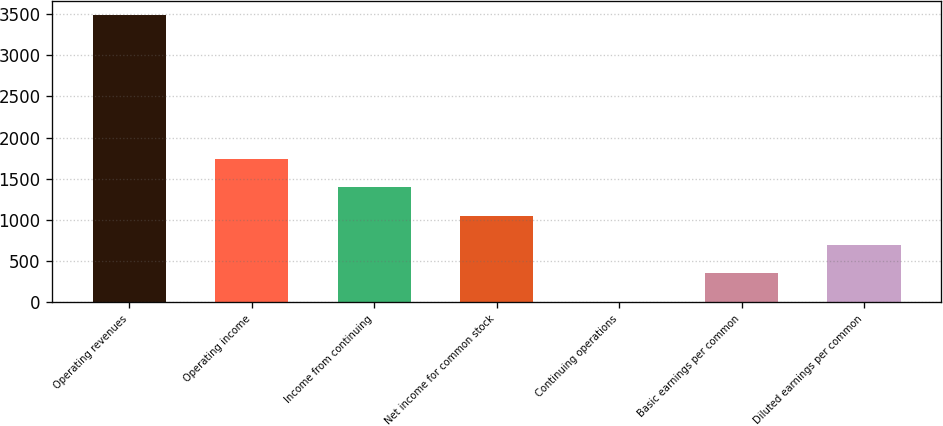Convert chart. <chart><loc_0><loc_0><loc_500><loc_500><bar_chart><fcel>Operating revenues<fcel>Operating income<fcel>Income from continuing<fcel>Net income for common stock<fcel>Continuing operations<fcel>Basic earnings per common<fcel>Diluted earnings per common<nl><fcel>3489<fcel>1745.12<fcel>1396.34<fcel>1047.56<fcel>1.22<fcel>350<fcel>698.78<nl></chart> 